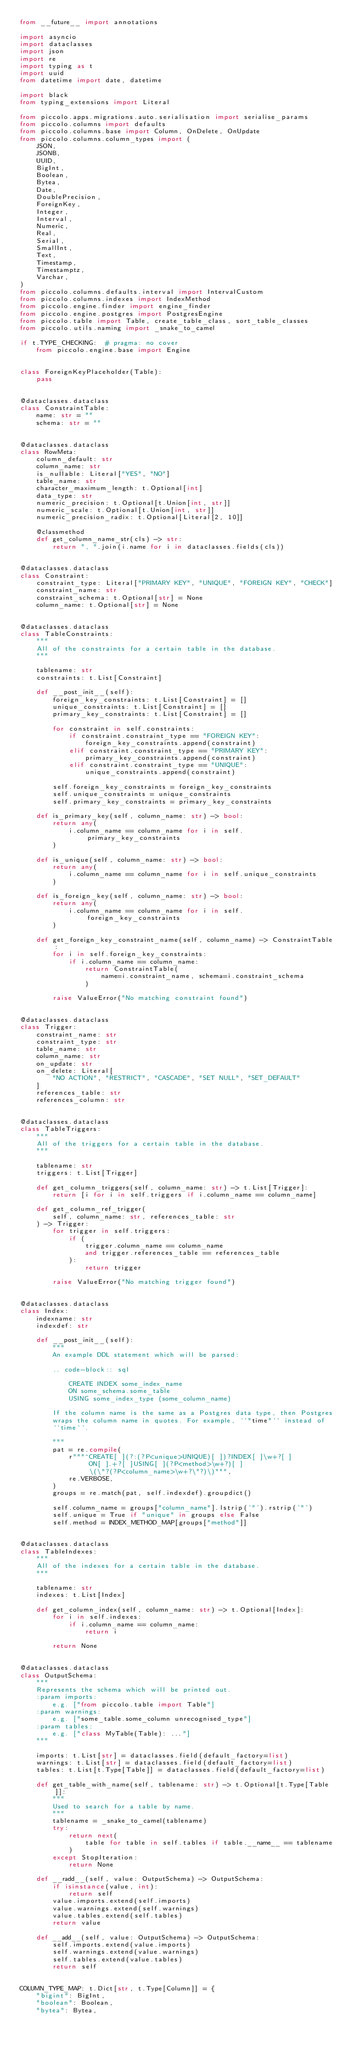<code> <loc_0><loc_0><loc_500><loc_500><_Python_>from __future__ import annotations

import asyncio
import dataclasses
import json
import re
import typing as t
import uuid
from datetime import date, datetime

import black
from typing_extensions import Literal

from piccolo.apps.migrations.auto.serialisation import serialise_params
from piccolo.columns import defaults
from piccolo.columns.base import Column, OnDelete, OnUpdate
from piccolo.columns.column_types import (
    JSON,
    JSONB,
    UUID,
    BigInt,
    Boolean,
    Bytea,
    Date,
    DoublePrecision,
    ForeignKey,
    Integer,
    Interval,
    Numeric,
    Real,
    Serial,
    SmallInt,
    Text,
    Timestamp,
    Timestamptz,
    Varchar,
)
from piccolo.columns.defaults.interval import IntervalCustom
from piccolo.columns.indexes import IndexMethod
from piccolo.engine.finder import engine_finder
from piccolo.engine.postgres import PostgresEngine
from piccolo.table import Table, create_table_class, sort_table_classes
from piccolo.utils.naming import _snake_to_camel

if t.TYPE_CHECKING:  # pragma: no cover
    from piccolo.engine.base import Engine


class ForeignKeyPlaceholder(Table):
    pass


@dataclasses.dataclass
class ConstraintTable:
    name: str = ""
    schema: str = ""


@dataclasses.dataclass
class RowMeta:
    column_default: str
    column_name: str
    is_nullable: Literal["YES", "NO"]
    table_name: str
    character_maximum_length: t.Optional[int]
    data_type: str
    numeric_precision: t.Optional[t.Union[int, str]]
    numeric_scale: t.Optional[t.Union[int, str]]
    numeric_precision_radix: t.Optional[Literal[2, 10]]

    @classmethod
    def get_column_name_str(cls) -> str:
        return ", ".join(i.name for i in dataclasses.fields(cls))


@dataclasses.dataclass
class Constraint:
    constraint_type: Literal["PRIMARY KEY", "UNIQUE", "FOREIGN KEY", "CHECK"]
    constraint_name: str
    constraint_schema: t.Optional[str] = None
    column_name: t.Optional[str] = None


@dataclasses.dataclass
class TableConstraints:
    """
    All of the constraints for a certain table in the database.
    """

    tablename: str
    constraints: t.List[Constraint]

    def __post_init__(self):
        foreign_key_constraints: t.List[Constraint] = []
        unique_constraints: t.List[Constraint] = []
        primary_key_constraints: t.List[Constraint] = []

        for constraint in self.constraints:
            if constraint.constraint_type == "FOREIGN KEY":
                foreign_key_constraints.append(constraint)
            elif constraint.constraint_type == "PRIMARY KEY":
                primary_key_constraints.append(constraint)
            elif constraint.constraint_type == "UNIQUE":
                unique_constraints.append(constraint)

        self.foreign_key_constraints = foreign_key_constraints
        self.unique_constraints = unique_constraints
        self.primary_key_constraints = primary_key_constraints

    def is_primary_key(self, column_name: str) -> bool:
        return any(
            i.column_name == column_name for i in self.primary_key_constraints
        )

    def is_unique(self, column_name: str) -> bool:
        return any(
            i.column_name == column_name for i in self.unique_constraints
        )

    def is_foreign_key(self, column_name: str) -> bool:
        return any(
            i.column_name == column_name for i in self.foreign_key_constraints
        )

    def get_foreign_key_constraint_name(self, column_name) -> ConstraintTable:
        for i in self.foreign_key_constraints:
            if i.column_name == column_name:
                return ConstraintTable(
                    name=i.constraint_name, schema=i.constraint_schema
                )

        raise ValueError("No matching constraint found")


@dataclasses.dataclass
class Trigger:
    constraint_name: str
    constraint_type: str
    table_name: str
    column_name: str
    on_update: str
    on_delete: Literal[
        "NO ACTION", "RESTRICT", "CASCADE", "SET NULL", "SET_DEFAULT"
    ]
    references_table: str
    references_column: str


@dataclasses.dataclass
class TableTriggers:
    """
    All of the triggers for a certain table in the database.
    """

    tablename: str
    triggers: t.List[Trigger]

    def get_column_triggers(self, column_name: str) -> t.List[Trigger]:
        return [i for i in self.triggers if i.column_name == column_name]

    def get_column_ref_trigger(
        self, column_name: str, references_table: str
    ) -> Trigger:
        for trigger in self.triggers:
            if (
                trigger.column_name == column_name
                and trigger.references_table == references_table
            ):
                return trigger

        raise ValueError("No matching trigger found")


@dataclasses.dataclass
class Index:
    indexname: str
    indexdef: str

    def __post_init__(self):
        """
        An example DDL statement which will be parsed:

        .. code-block:: sql

            CREATE INDEX some_index_name
            ON some_schema.some_table
            USING some_index_type (some_column_name)

        If the column name is the same as a Postgres data type, then Postgres
        wraps the column name in quotes. For example, ``"time"`` instead of
        ``time``.

        """
        pat = re.compile(
            r"""^CREATE[ ](?:(?P<unique>UNIQUE)[ ])?INDEX[ ]\w+?[ ]
                 ON[ ].+?[ ]USING[ ](?P<method>\w+?)[ ]
                 \(\"?(?P<column_name>\w+?\"?)\)""",
            re.VERBOSE,
        )
        groups = re.match(pat, self.indexdef).groupdict()

        self.column_name = groups["column_name"].lstrip('"').rstrip('"')
        self.unique = True if "unique" in groups else False
        self.method = INDEX_METHOD_MAP[groups["method"]]


@dataclasses.dataclass
class TableIndexes:
    """
    All of the indexes for a certain table in the database.
    """

    tablename: str
    indexes: t.List[Index]

    def get_column_index(self, column_name: str) -> t.Optional[Index]:
        for i in self.indexes:
            if i.column_name == column_name:
                return i

        return None


@dataclasses.dataclass
class OutputSchema:
    """
    Represents the schema which will be printed out.
    :param imports:
        e.g. ["from piccolo.table import Table"]
    :param warnings:
        e.g. ["some_table.some_column unrecognised_type"]
    :param tables:
        e.g. ["class MyTable(Table): ..."]
    """

    imports: t.List[str] = dataclasses.field(default_factory=list)
    warnings: t.List[str] = dataclasses.field(default_factory=list)
    tables: t.List[t.Type[Table]] = dataclasses.field(default_factory=list)

    def get_table_with_name(self, tablename: str) -> t.Optional[t.Type[Table]]:
        """
        Used to search for a table by name.
        """
        tablename = _snake_to_camel(tablename)
        try:
            return next(
                table for table in self.tables if table.__name__ == tablename
            )
        except StopIteration:
            return None

    def __radd__(self, value: OutputSchema) -> OutputSchema:
        if isinstance(value, int):
            return self
        value.imports.extend(self.imports)
        value.warnings.extend(self.warnings)
        value.tables.extend(self.tables)
        return value

    def __add__(self, value: OutputSchema) -> OutputSchema:
        self.imports.extend(value.imports)
        self.warnings.extend(value.warnings)
        self.tables.extend(value.tables)
        return self


COLUMN_TYPE_MAP: t.Dict[str, t.Type[Column]] = {
    "bigint": BigInt,
    "boolean": Boolean,
    "bytea": Bytea,</code> 